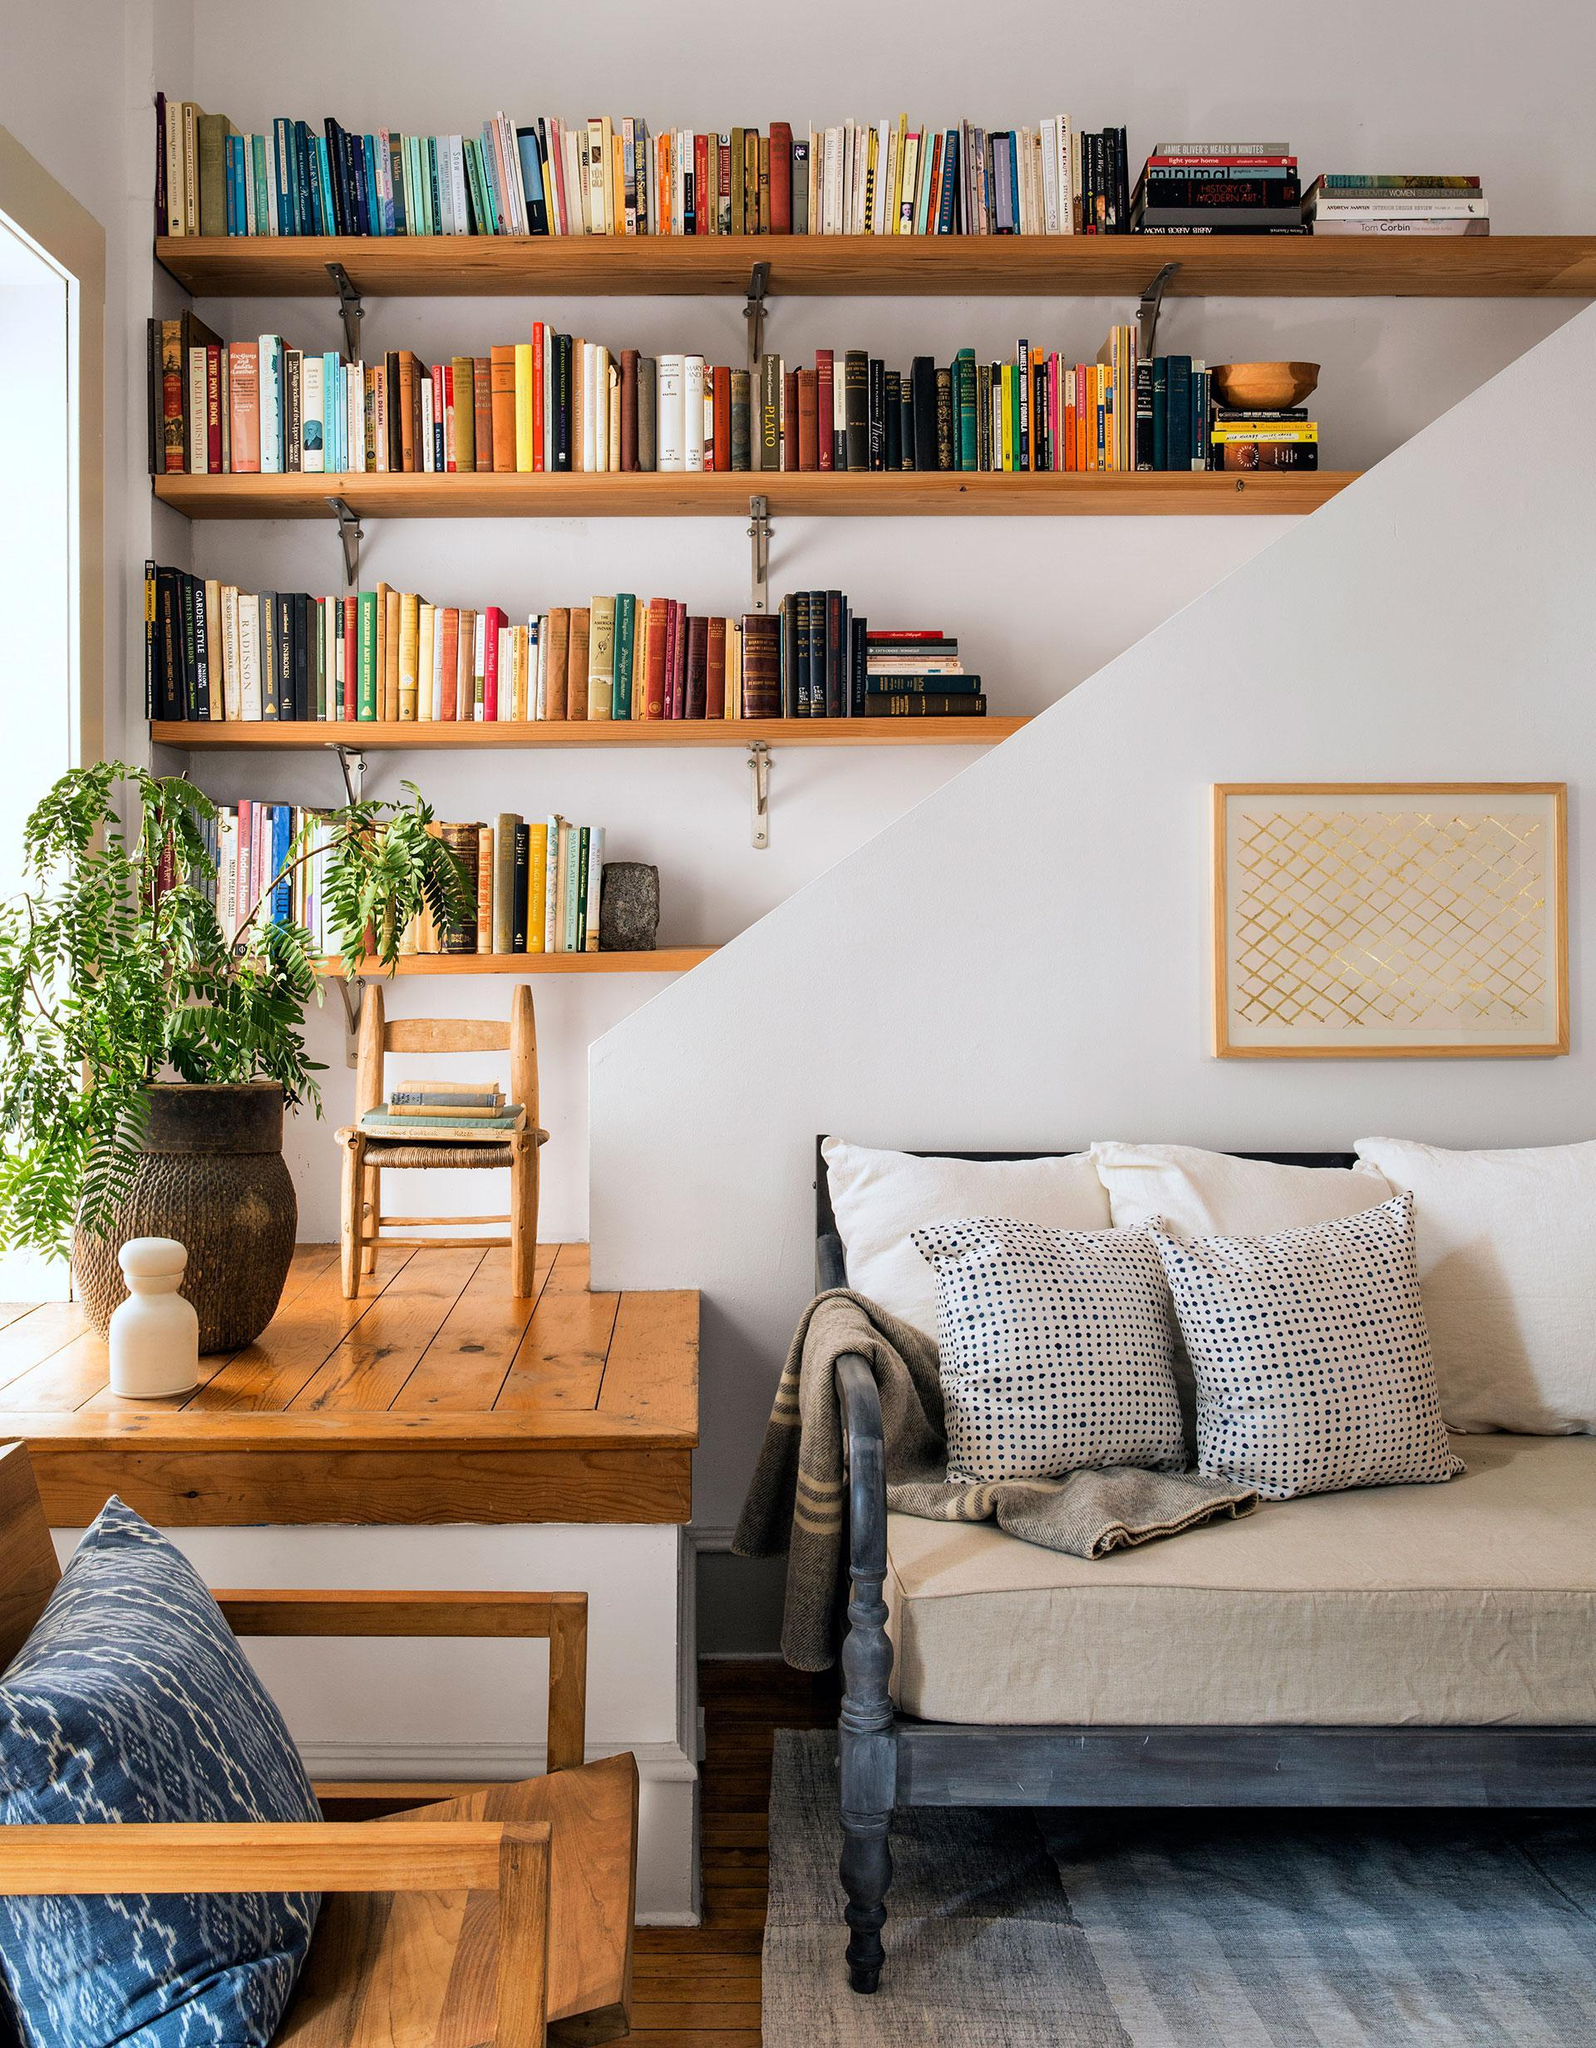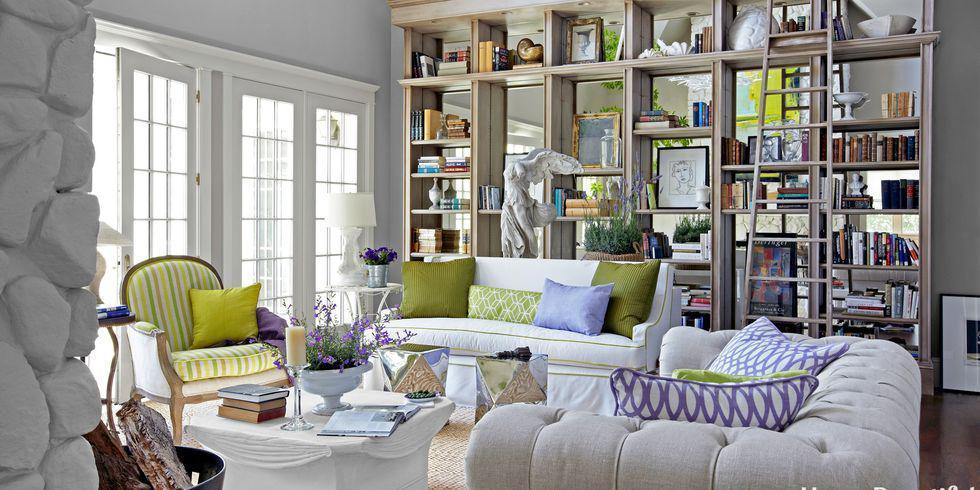The first image is the image on the left, the second image is the image on the right. Considering the images on both sides, is "The right image shows a ladder leaned up against the front of a stocked bookshelf." valid? Answer yes or no. Yes. The first image is the image on the left, the second image is the image on the right. Considering the images on both sides, is "In one image, a wall bookshelf unit with at least six shelves has at least one piece of framed artwork mounted to the front of the shelf, obscuring some of the contents." valid? Answer yes or no. No. 